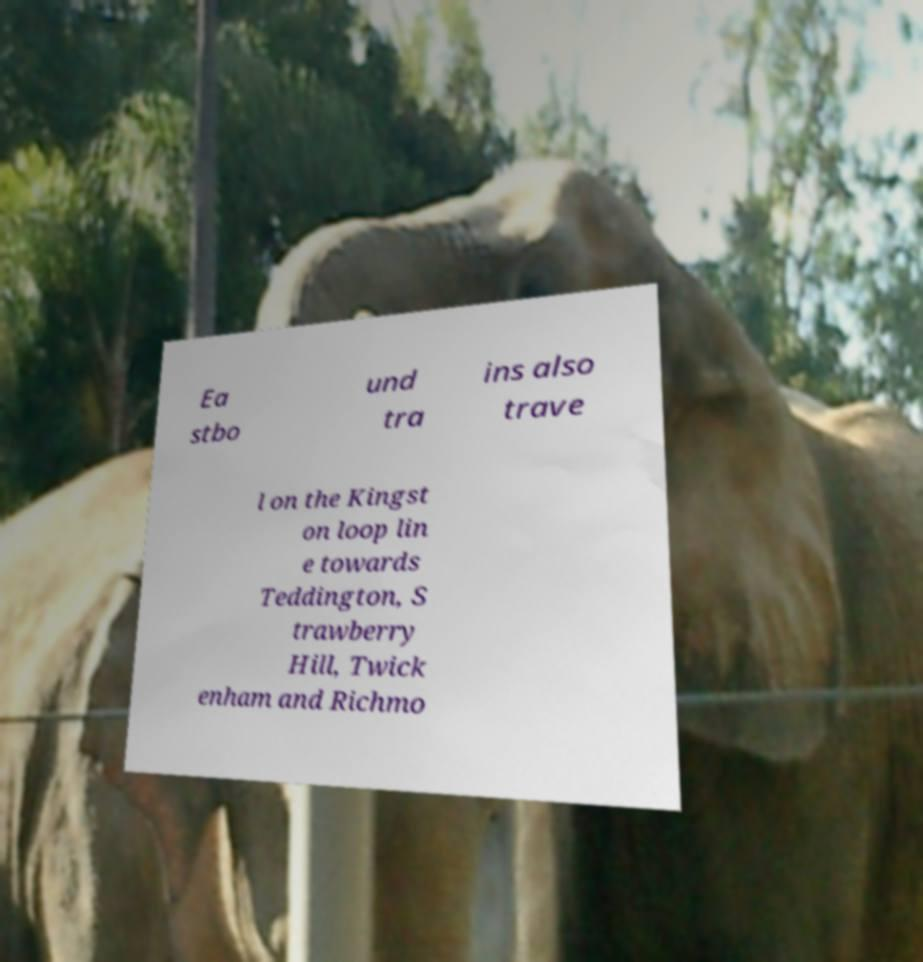There's text embedded in this image that I need extracted. Can you transcribe it verbatim? Ea stbo und tra ins also trave l on the Kingst on loop lin e towards Teddington, S trawberry Hill, Twick enham and Richmo 